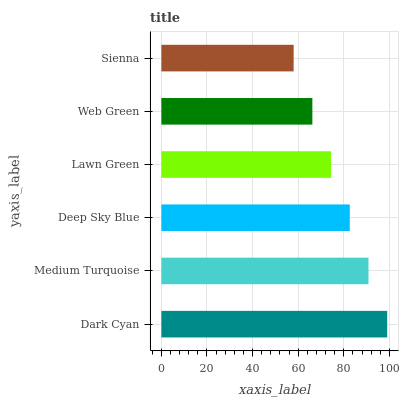Is Sienna the minimum?
Answer yes or no. Yes. Is Dark Cyan the maximum?
Answer yes or no. Yes. Is Medium Turquoise the minimum?
Answer yes or no. No. Is Medium Turquoise the maximum?
Answer yes or no. No. Is Dark Cyan greater than Medium Turquoise?
Answer yes or no. Yes. Is Medium Turquoise less than Dark Cyan?
Answer yes or no. Yes. Is Medium Turquoise greater than Dark Cyan?
Answer yes or no. No. Is Dark Cyan less than Medium Turquoise?
Answer yes or no. No. Is Deep Sky Blue the high median?
Answer yes or no. Yes. Is Lawn Green the low median?
Answer yes or no. Yes. Is Medium Turquoise the high median?
Answer yes or no. No. Is Sienna the low median?
Answer yes or no. No. 